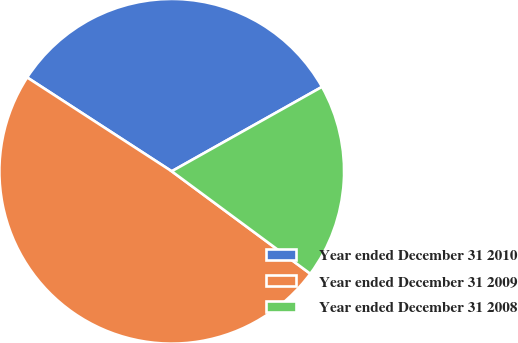Convert chart. <chart><loc_0><loc_0><loc_500><loc_500><pie_chart><fcel>Year ended December 31 2010<fcel>Year ended December 31 2009<fcel>Year ended December 31 2008<nl><fcel>32.69%<fcel>49.03%<fcel>18.28%<nl></chart> 